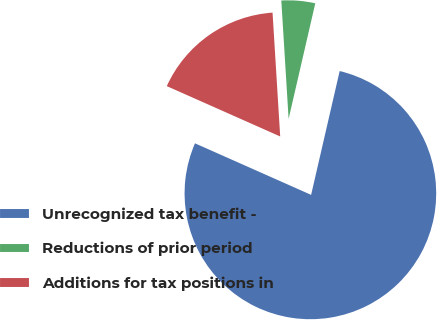Convert chart to OTSL. <chart><loc_0><loc_0><loc_500><loc_500><pie_chart><fcel>Unrecognized tax benefit -<fcel>Reductions of prior period<fcel>Additions for tax positions in<nl><fcel>78.04%<fcel>4.59%<fcel>17.37%<nl></chart> 